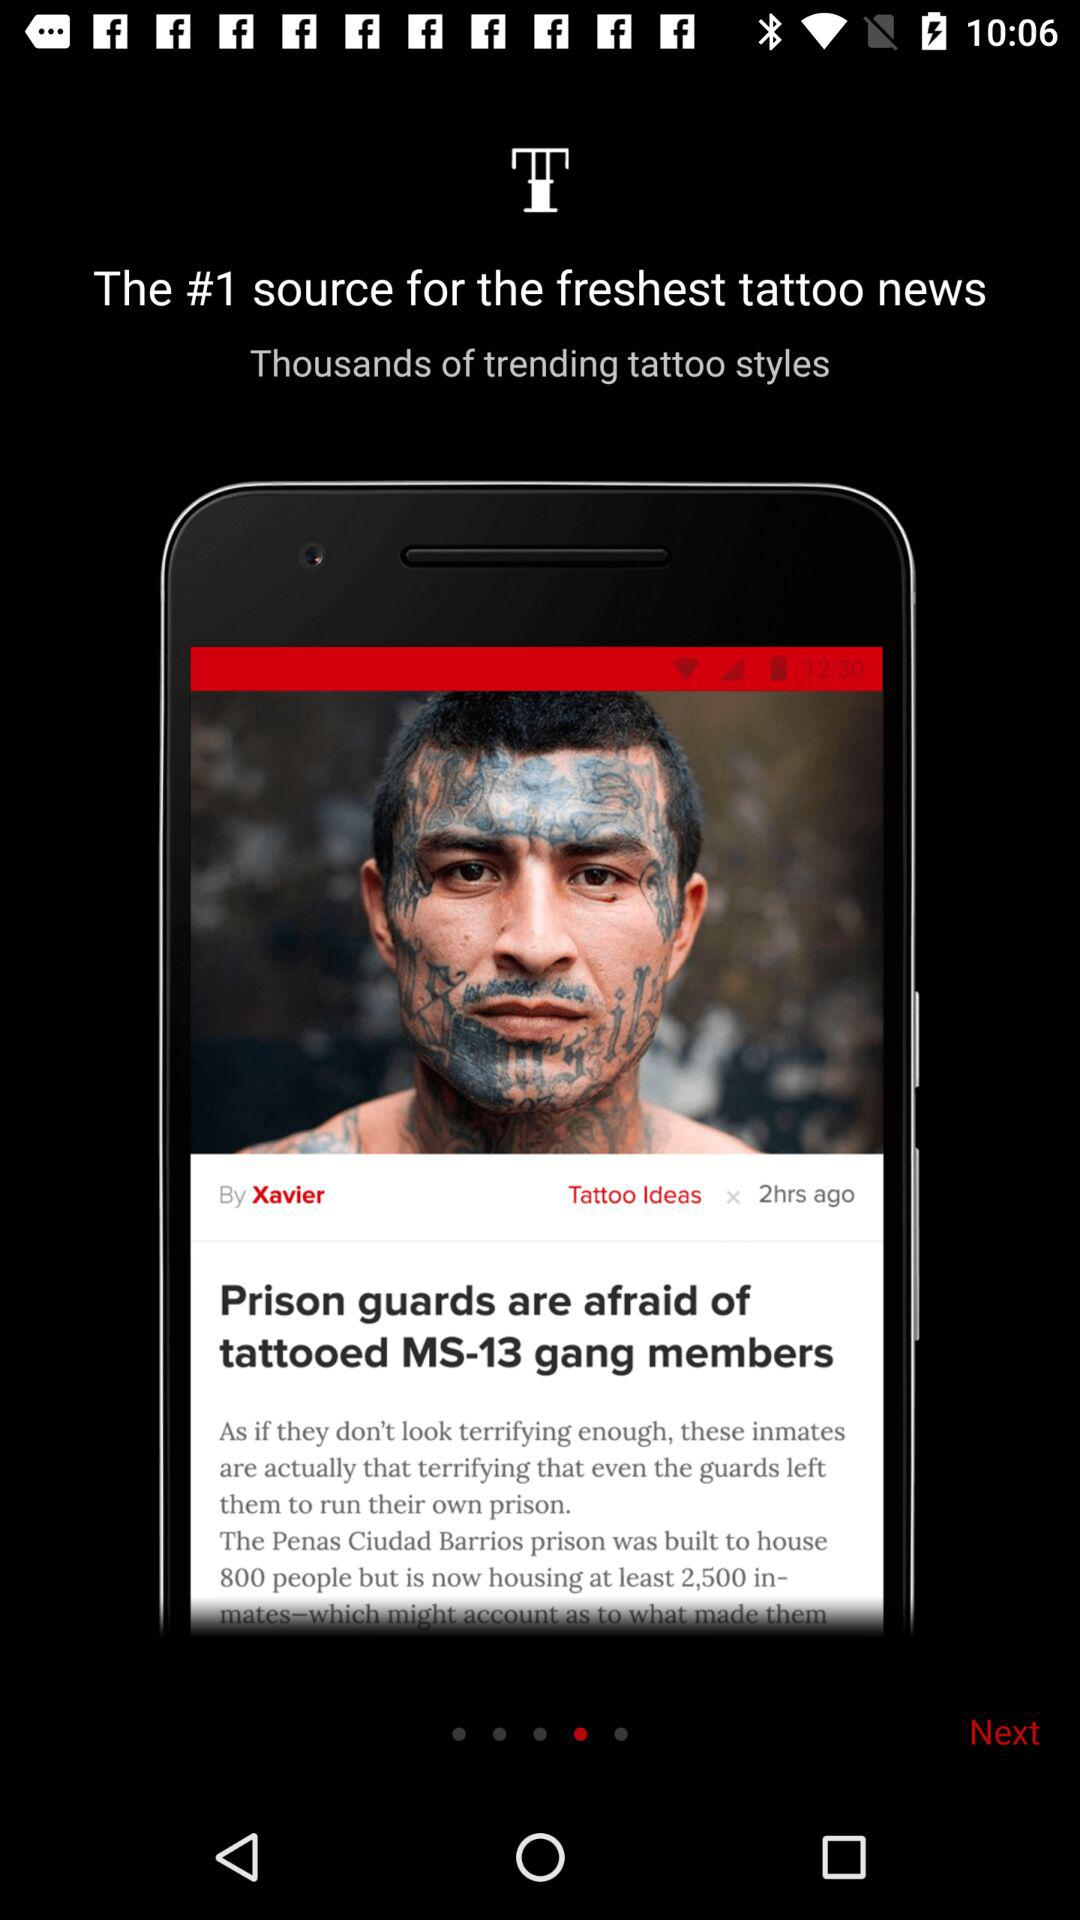What is the name of the gang? The name of the gang is "MS-13". 